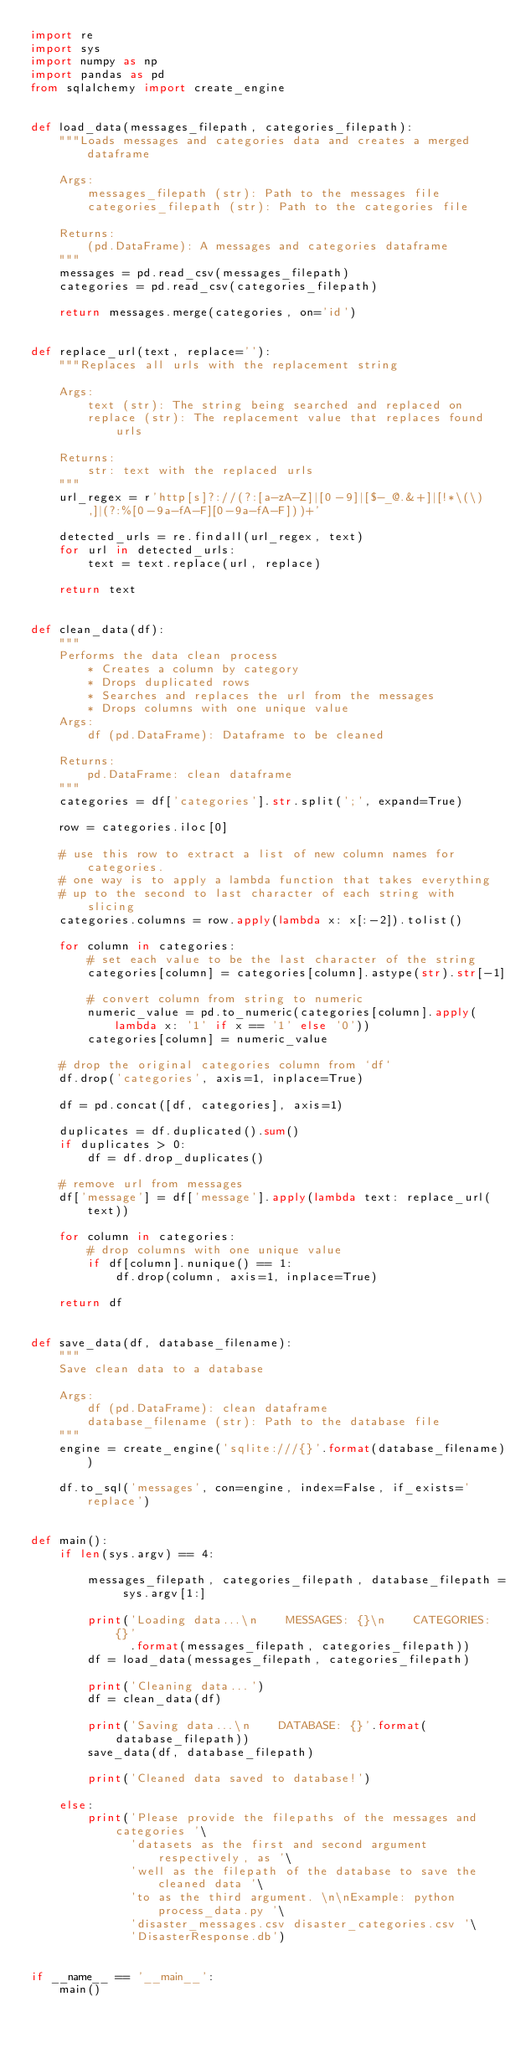<code> <loc_0><loc_0><loc_500><loc_500><_Python_>import re
import sys
import numpy as np
import pandas as pd
from sqlalchemy import create_engine


def load_data(messages_filepath, categories_filepath):
    """Loads messages and categories data and creates a merged dataframe

    Args:
        messages_filepath (str): Path to the messages file
        categories_filepath (str): Path to the categories file

    Returns:
        (pd.DataFrame): A messages and categories dataframe
    """
    messages = pd.read_csv(messages_filepath)
    categories = pd.read_csv(categories_filepath)

    return messages.merge(categories, on='id')


def replace_url(text, replace=''):
    """Replaces all urls with the replacement string

    Args:
        text (str): The string being searched and replaced on
        replace (str): The replacement value that replaces found urls

    Returns:
        str: text with the replaced urls
    """
    url_regex = r'http[s]?://(?:[a-zA-Z]|[0-9]|[$-_@.&+]|[!*\(\),]|(?:%[0-9a-fA-F][0-9a-fA-F]))+'

    detected_urls = re.findall(url_regex, text)
    for url in detected_urls:
        text = text.replace(url, replace)

    return text


def clean_data(df):
    """
    Performs the data clean process
        * Creates a column by category
        * Drops duplicated rows
        * Searches and replaces the url from the messages
        * Drops columns with one unique value
    Args:
        df (pd.DataFrame): Dataframe to be cleaned

    Returns:
        pd.DataFrame: clean dataframe
    """
    categories = df['categories'].str.split(';', expand=True)

    row = categories.iloc[0]

    # use this row to extract a list of new column names for categories.
    # one way is to apply a lambda function that takes everything 
    # up to the second to last character of each string with slicing
    categories.columns = row.apply(lambda x: x[:-2]).tolist()

    for column in categories:
        # set each value to be the last character of the string
        categories[column] = categories[column].astype(str).str[-1]

        # convert column from string to numeric
        numeric_value = pd.to_numeric(categories[column].apply(lambda x: '1' if x == '1' else '0'))
        categories[column] = numeric_value

    # drop the original categories column from `df`
    df.drop('categories', axis=1, inplace=True)

    df = pd.concat([df, categories], axis=1)

    duplicates = df.duplicated().sum()
    if duplicates > 0:
        df = df.drop_duplicates()

    # remove url from messages
    df['message'] = df['message'].apply(lambda text: replace_url(text))

    for column in categories:
        # drop columns with one unique value
        if df[column].nunique() == 1:
            df.drop(column, axis=1, inplace=True)

    return df


def save_data(df, database_filename):
    """
    Save clean data to a database

    Args:
        df (pd.DataFrame): clean dataframe
        database_filename (str): Path to the database file
    """
    engine = create_engine('sqlite:///{}'.format(database_filename))

    df.to_sql('messages', con=engine, index=False, if_exists='replace')


def main():
    if len(sys.argv) == 4:

        messages_filepath, categories_filepath, database_filepath = sys.argv[1:]

        print('Loading data...\n    MESSAGES: {}\n    CATEGORIES: {}'
              .format(messages_filepath, categories_filepath))
        df = load_data(messages_filepath, categories_filepath)

        print('Cleaning data...')
        df = clean_data(df)

        print('Saving data...\n    DATABASE: {}'.format(database_filepath))
        save_data(df, database_filepath)

        print('Cleaned data saved to database!')

    else:
        print('Please provide the filepaths of the messages and categories '\
              'datasets as the first and second argument respectively, as '\
              'well as the filepath of the database to save the cleaned data '\
              'to as the third argument. \n\nExample: python process_data.py '\
              'disaster_messages.csv disaster_categories.csv '\
              'DisasterResponse.db')


if __name__ == '__main__':
    main()
</code> 